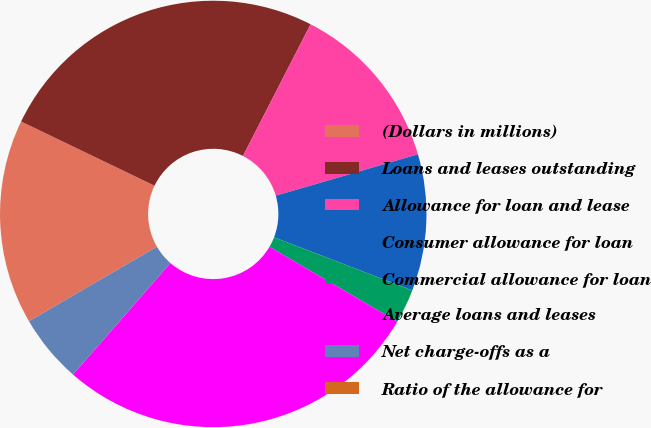<chart> <loc_0><loc_0><loc_500><loc_500><pie_chart><fcel>(Dollars in millions)<fcel>Loans and leases outstanding<fcel>Allowance for loan and lease<fcel>Consumer allowance for loan<fcel>Commercial allowance for loan<fcel>Average loans and leases<fcel>Net charge-offs as a<fcel>Ratio of the allowance for<nl><fcel>15.53%<fcel>25.41%<fcel>12.94%<fcel>10.35%<fcel>2.59%<fcel>28.0%<fcel>5.18%<fcel>0.0%<nl></chart> 